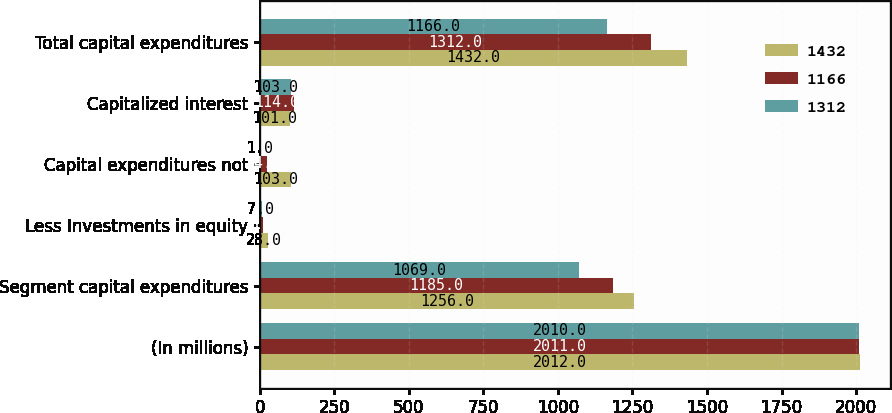<chart> <loc_0><loc_0><loc_500><loc_500><stacked_bar_chart><ecel><fcel>(In millions)<fcel>Segment capital expenditures<fcel>Less Investments in equity<fcel>Capital expenditures not<fcel>Capitalized interest<fcel>Total capital expenditures<nl><fcel>1432<fcel>2012<fcel>1256<fcel>28<fcel>103<fcel>101<fcel>1432<nl><fcel>1166<fcel>2011<fcel>1185<fcel>11<fcel>24<fcel>114<fcel>1312<nl><fcel>1312<fcel>2010<fcel>1069<fcel>7<fcel>1<fcel>103<fcel>1166<nl></chart> 